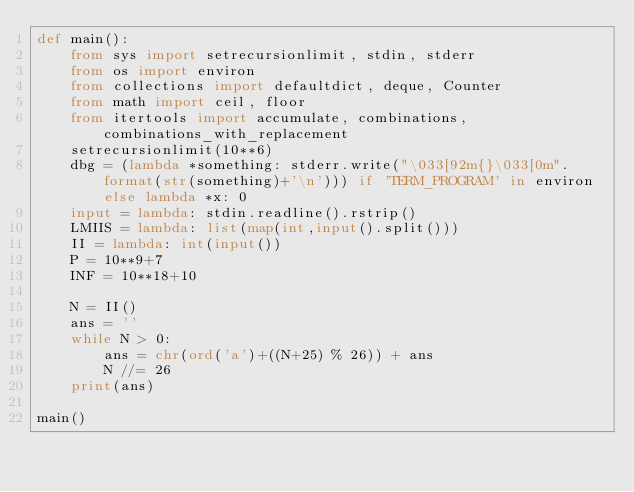Convert code to text. <code><loc_0><loc_0><loc_500><loc_500><_Python_>def main():
    from sys import setrecursionlimit, stdin, stderr
    from os import environ
    from collections import defaultdict, deque, Counter
    from math import ceil, floor
    from itertools import accumulate, combinations, combinations_with_replacement
    setrecursionlimit(10**6)
    dbg = (lambda *something: stderr.write("\033[92m{}\033[0m".format(str(something)+'\n'))) if 'TERM_PROGRAM' in environ else lambda *x: 0
    input = lambda: stdin.readline().rstrip()
    LMIIS = lambda: list(map(int,input().split()))
    II = lambda: int(input())
    P = 10**9+7
    INF = 10**18+10

    N = II()
    ans = ''
    while N > 0:
        ans = chr(ord('a')+((N+25) % 26)) + ans
        N //= 26
    print(ans) 
    
main()</code> 